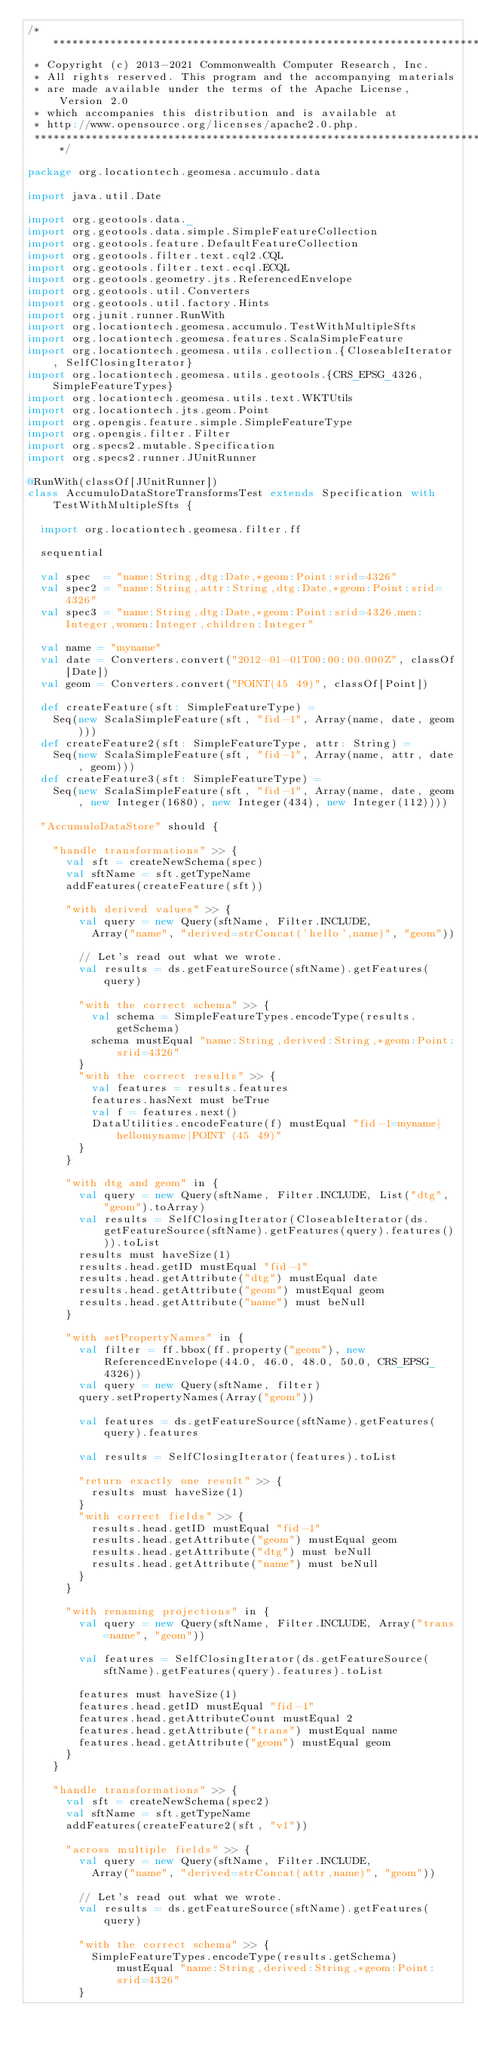<code> <loc_0><loc_0><loc_500><loc_500><_Scala_>/***********************************************************************
 * Copyright (c) 2013-2021 Commonwealth Computer Research, Inc.
 * All rights reserved. This program and the accompanying materials
 * are made available under the terms of the Apache License, Version 2.0
 * which accompanies this distribution and is available at
 * http://www.opensource.org/licenses/apache2.0.php.
 ***********************************************************************/

package org.locationtech.geomesa.accumulo.data

import java.util.Date

import org.geotools.data._
import org.geotools.data.simple.SimpleFeatureCollection
import org.geotools.feature.DefaultFeatureCollection
import org.geotools.filter.text.cql2.CQL
import org.geotools.filter.text.ecql.ECQL
import org.geotools.geometry.jts.ReferencedEnvelope
import org.geotools.util.Converters
import org.geotools.util.factory.Hints
import org.junit.runner.RunWith
import org.locationtech.geomesa.accumulo.TestWithMultipleSfts
import org.locationtech.geomesa.features.ScalaSimpleFeature
import org.locationtech.geomesa.utils.collection.{CloseableIterator, SelfClosingIterator}
import org.locationtech.geomesa.utils.geotools.{CRS_EPSG_4326, SimpleFeatureTypes}
import org.locationtech.geomesa.utils.text.WKTUtils
import org.locationtech.jts.geom.Point
import org.opengis.feature.simple.SimpleFeatureType
import org.opengis.filter.Filter
import org.specs2.mutable.Specification
import org.specs2.runner.JUnitRunner

@RunWith(classOf[JUnitRunner])
class AccumuloDataStoreTransformsTest extends Specification with TestWithMultipleSfts {

  import org.locationtech.geomesa.filter.ff

  sequential

  val spec  = "name:String,dtg:Date,*geom:Point:srid=4326"
  val spec2 = "name:String,attr:String,dtg:Date,*geom:Point:srid=4326"
  val spec3 = "name:String,dtg:Date,*geom:Point:srid=4326,men:Integer,women:Integer,children:Integer"

  val name = "myname"
  val date = Converters.convert("2012-01-01T00:00:00.000Z", classOf[Date])
  val geom = Converters.convert("POINT(45 49)", classOf[Point])

  def createFeature(sft: SimpleFeatureType) =
    Seq(new ScalaSimpleFeature(sft, "fid-1", Array(name, date, geom)))
  def createFeature2(sft: SimpleFeatureType, attr: String) =
    Seq(new ScalaSimpleFeature(sft, "fid-1", Array(name, attr, date, geom)))
  def createFeature3(sft: SimpleFeatureType) =
    Seq(new ScalaSimpleFeature(sft, "fid-1", Array(name, date, geom, new Integer(1680), new Integer(434), new Integer(112))))

  "AccumuloDataStore" should {

    "handle transformations" >> {
      val sft = createNewSchema(spec)
      val sftName = sft.getTypeName
      addFeatures(createFeature(sft))

      "with derived values" >> {
        val query = new Query(sftName, Filter.INCLUDE,
          Array("name", "derived=strConcat('hello',name)", "geom"))

        // Let's read out what we wrote.
        val results = ds.getFeatureSource(sftName).getFeatures(query)

        "with the correct schema" >> {
          val schema = SimpleFeatureTypes.encodeType(results.getSchema)
          schema mustEqual "name:String,derived:String,*geom:Point:srid=4326"
        }
        "with the correct results" >> {
          val features = results.features
          features.hasNext must beTrue
          val f = features.next()
          DataUtilities.encodeFeature(f) mustEqual "fid-1=myname|hellomyname|POINT (45 49)"
        }
      }

      "with dtg and geom" in {
        val query = new Query(sftName, Filter.INCLUDE, List("dtg", "geom").toArray)
        val results = SelfClosingIterator(CloseableIterator(ds.getFeatureSource(sftName).getFeatures(query).features())).toList
        results must haveSize(1)
        results.head.getID mustEqual "fid-1"
        results.head.getAttribute("dtg") mustEqual date
        results.head.getAttribute("geom") mustEqual geom
        results.head.getAttribute("name") must beNull
      }

      "with setPropertyNames" in {
        val filter = ff.bbox(ff.property("geom"), new ReferencedEnvelope(44.0, 46.0, 48.0, 50.0, CRS_EPSG_4326))
        val query = new Query(sftName, filter)
        query.setPropertyNames(Array("geom"))

        val features = ds.getFeatureSource(sftName).getFeatures(query).features

        val results = SelfClosingIterator(features).toList

        "return exactly one result" >> {
          results must haveSize(1)
        }
        "with correct fields" >> {
          results.head.getID mustEqual "fid-1"
          results.head.getAttribute("geom") mustEqual geom
          results.head.getAttribute("dtg") must beNull
          results.head.getAttribute("name") must beNull
        }
      }

      "with renaming projections" in {
        val query = new Query(sftName, Filter.INCLUDE, Array("trans=name", "geom"))

        val features = SelfClosingIterator(ds.getFeatureSource(sftName).getFeatures(query).features).toList

        features must haveSize(1)
        features.head.getID mustEqual "fid-1"
        features.head.getAttributeCount mustEqual 2
        features.head.getAttribute("trans") mustEqual name
        features.head.getAttribute("geom") mustEqual geom
      }
    }

    "handle transformations" >> {
      val sft = createNewSchema(spec2)
      val sftName = sft.getTypeName
      addFeatures(createFeature2(sft, "v1"))

      "across multiple fields" >> {
        val query = new Query(sftName, Filter.INCLUDE,
          Array("name", "derived=strConcat(attr,name)", "geom"))

        // Let's read out what we wrote.
        val results = ds.getFeatureSource(sftName).getFeatures(query)

        "with the correct schema" >> {
          SimpleFeatureTypes.encodeType(results.getSchema) mustEqual "name:String,derived:String,*geom:Point:srid=4326"
        }</code> 